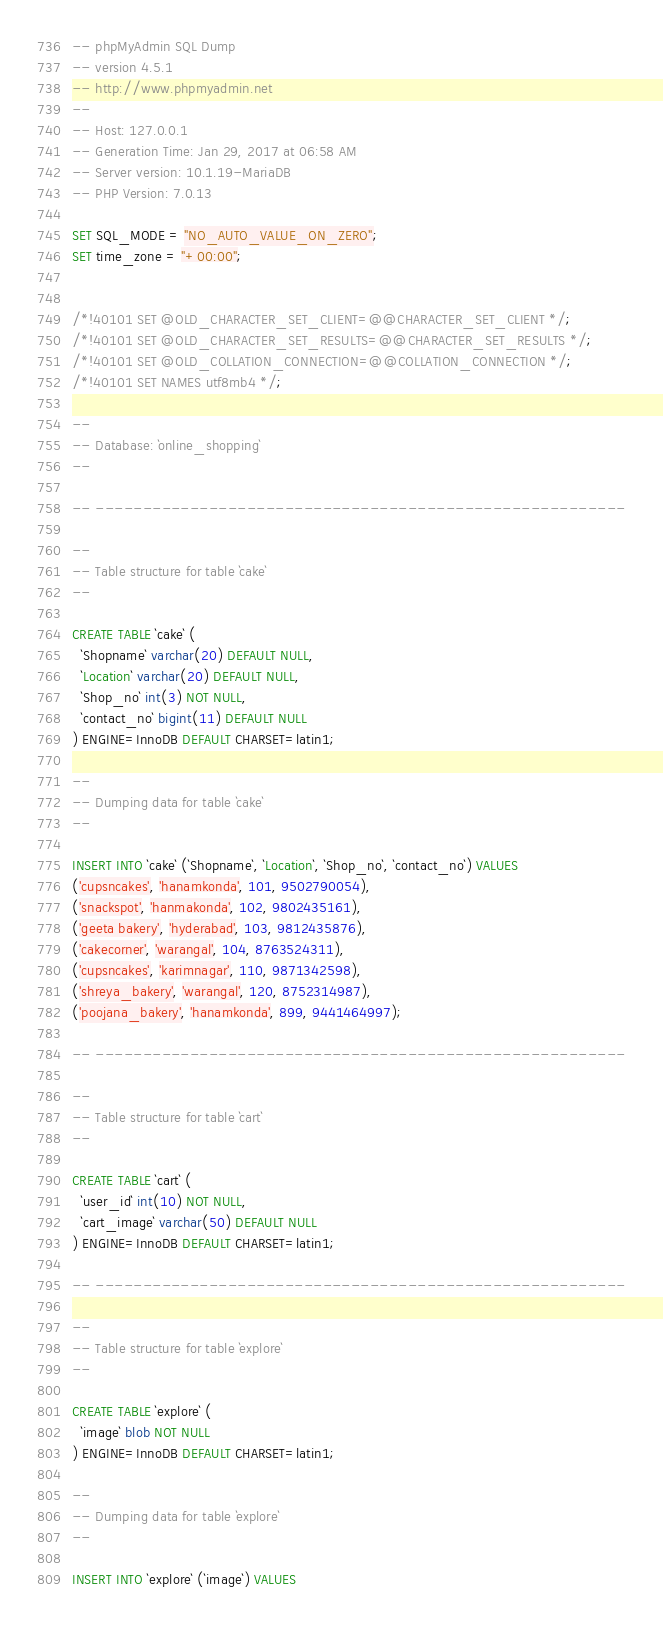Convert code to text. <code><loc_0><loc_0><loc_500><loc_500><_SQL_>-- phpMyAdmin SQL Dump
-- version 4.5.1
-- http://www.phpmyadmin.net
--
-- Host: 127.0.0.1
-- Generation Time: Jan 29, 2017 at 06:58 AM
-- Server version: 10.1.19-MariaDB
-- PHP Version: 7.0.13

SET SQL_MODE = "NO_AUTO_VALUE_ON_ZERO";
SET time_zone = "+00:00";


/*!40101 SET @OLD_CHARACTER_SET_CLIENT=@@CHARACTER_SET_CLIENT */;
/*!40101 SET @OLD_CHARACTER_SET_RESULTS=@@CHARACTER_SET_RESULTS */;
/*!40101 SET @OLD_COLLATION_CONNECTION=@@COLLATION_CONNECTION */;
/*!40101 SET NAMES utf8mb4 */;

--
-- Database: `online_shopping`
--

-- --------------------------------------------------------

--
-- Table structure for table `cake`
--

CREATE TABLE `cake` (
  `Shopname` varchar(20) DEFAULT NULL,
  `Location` varchar(20) DEFAULT NULL,
  `Shop_no` int(3) NOT NULL,
  `contact_no` bigint(11) DEFAULT NULL
) ENGINE=InnoDB DEFAULT CHARSET=latin1;

--
-- Dumping data for table `cake`
--

INSERT INTO `cake` (`Shopname`, `Location`, `Shop_no`, `contact_no`) VALUES
('cupsncakes', 'hanamkonda', 101, 9502790054),
('snackspot', 'hanmakonda', 102, 9802435161),
('geeta bakery', 'hyderabad', 103, 9812435876),
('cakecorner', 'warangal', 104, 8763524311),
('cupsncakes', 'karimnagar', 110, 9871342598),
('shreya_bakery', 'warangal', 120, 8752314987),
('poojana_bakery', 'hanamkonda', 899, 9441464997);

-- --------------------------------------------------------

--
-- Table structure for table `cart`
--

CREATE TABLE `cart` (
  `user_id` int(10) NOT NULL,
  `cart_image` varchar(50) DEFAULT NULL
) ENGINE=InnoDB DEFAULT CHARSET=latin1;

-- --------------------------------------------------------

--
-- Table structure for table `explore`
--

CREATE TABLE `explore` (
  `image` blob NOT NULL
) ENGINE=InnoDB DEFAULT CHARSET=latin1;

--
-- Dumping data for table `explore`
--

INSERT INTO `explore` (`image`) VALUES</code> 